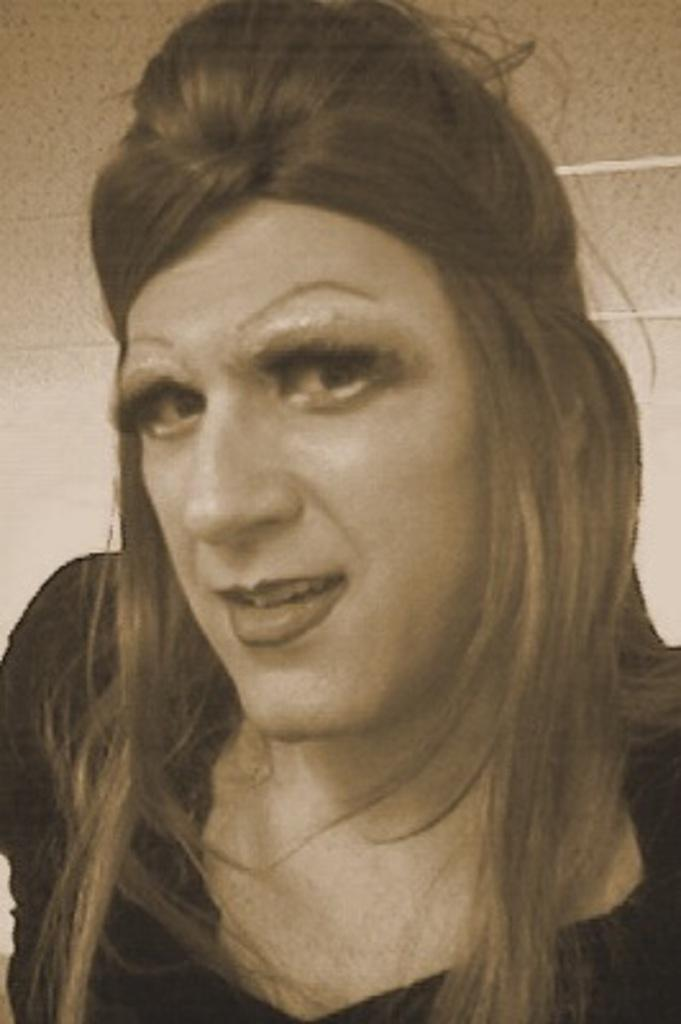What is the main subject of the picture? There is a person in the picture. What is the person wearing in the image? The person is wearing a black dress. What is the person doing in the picture? The person is posing for a photograph. What type of design can be seen on the person's dress in the image? There is no specific design mentioned on the person's dress in the provided facts, so it cannot be determined from the image. 